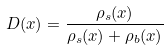Convert formula to latex. <formula><loc_0><loc_0><loc_500><loc_500>D ( x ) = \frac { \rho _ { s } ( x ) } { \rho _ { s } ( x ) + \rho _ { b } ( x ) }</formula> 